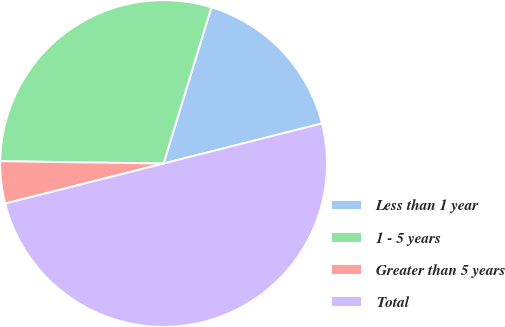<chart> <loc_0><loc_0><loc_500><loc_500><pie_chart><fcel>Less than 1 year<fcel>1 - 5 years<fcel>Greater than 5 years<fcel>Total<nl><fcel>16.33%<fcel>29.5%<fcel>4.17%<fcel>50.0%<nl></chart> 